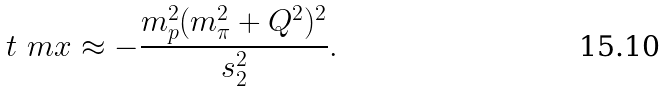Convert formula to latex. <formula><loc_0><loc_0><loc_500><loc_500>t _ { \ } m x \approx - \frac { m _ { p } ^ { 2 } ( m _ { \pi } ^ { 2 } + Q ^ { 2 } ) ^ { 2 } } { s _ { 2 } ^ { 2 } } .</formula> 